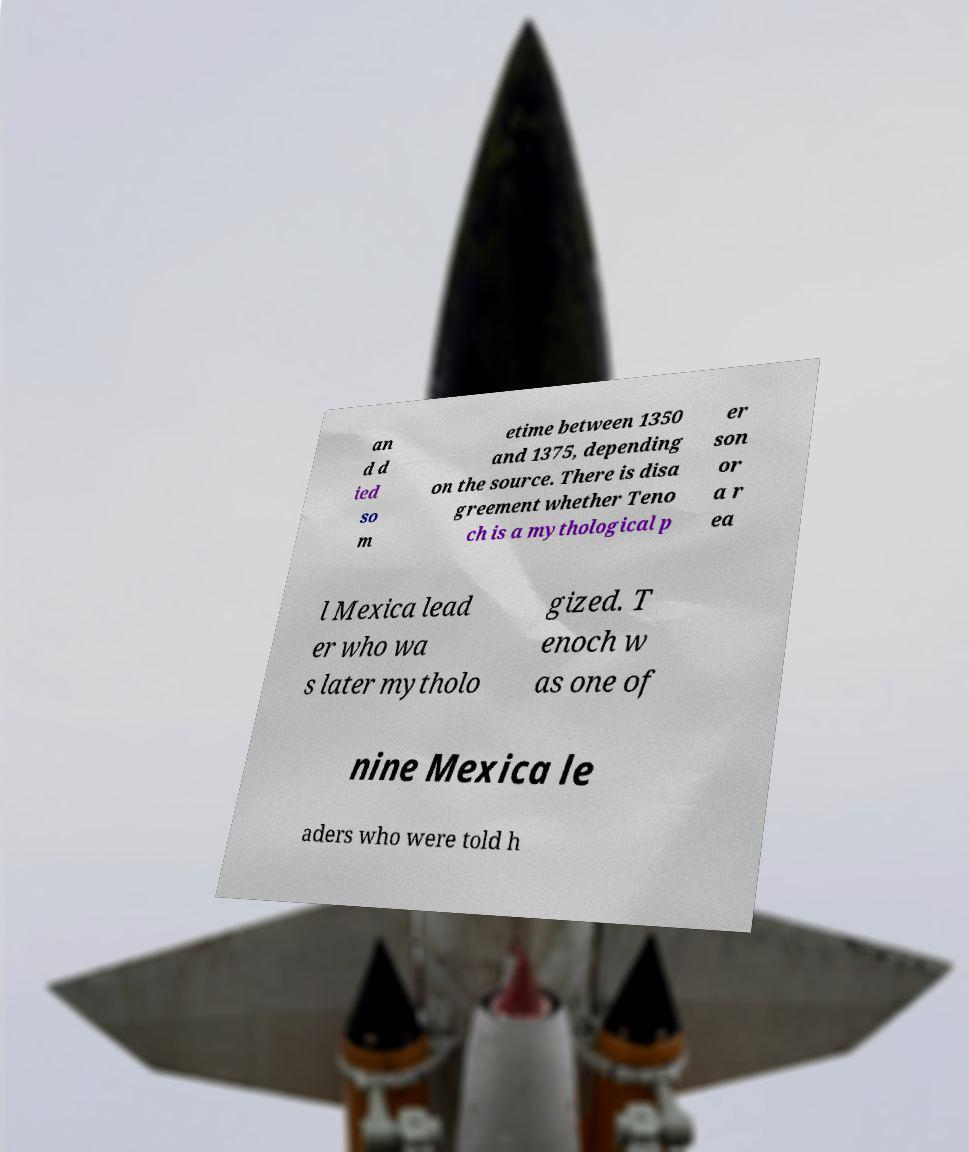Could you extract and type out the text from this image? an d d ied so m etime between 1350 and 1375, depending on the source. There is disa greement whether Teno ch is a mythological p er son or a r ea l Mexica lead er who wa s later mytholo gized. T enoch w as one of nine Mexica le aders who were told h 